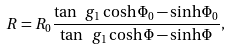Convert formula to latex. <formula><loc_0><loc_0><loc_500><loc_500>R = R _ { 0 } \frac { \tan \ g _ { 1 } \cosh \Phi _ { 0 } - \sinh \Phi _ { 0 } } { \tan \ g _ { 1 } \cosh \Phi - \sinh \Phi } ,</formula> 